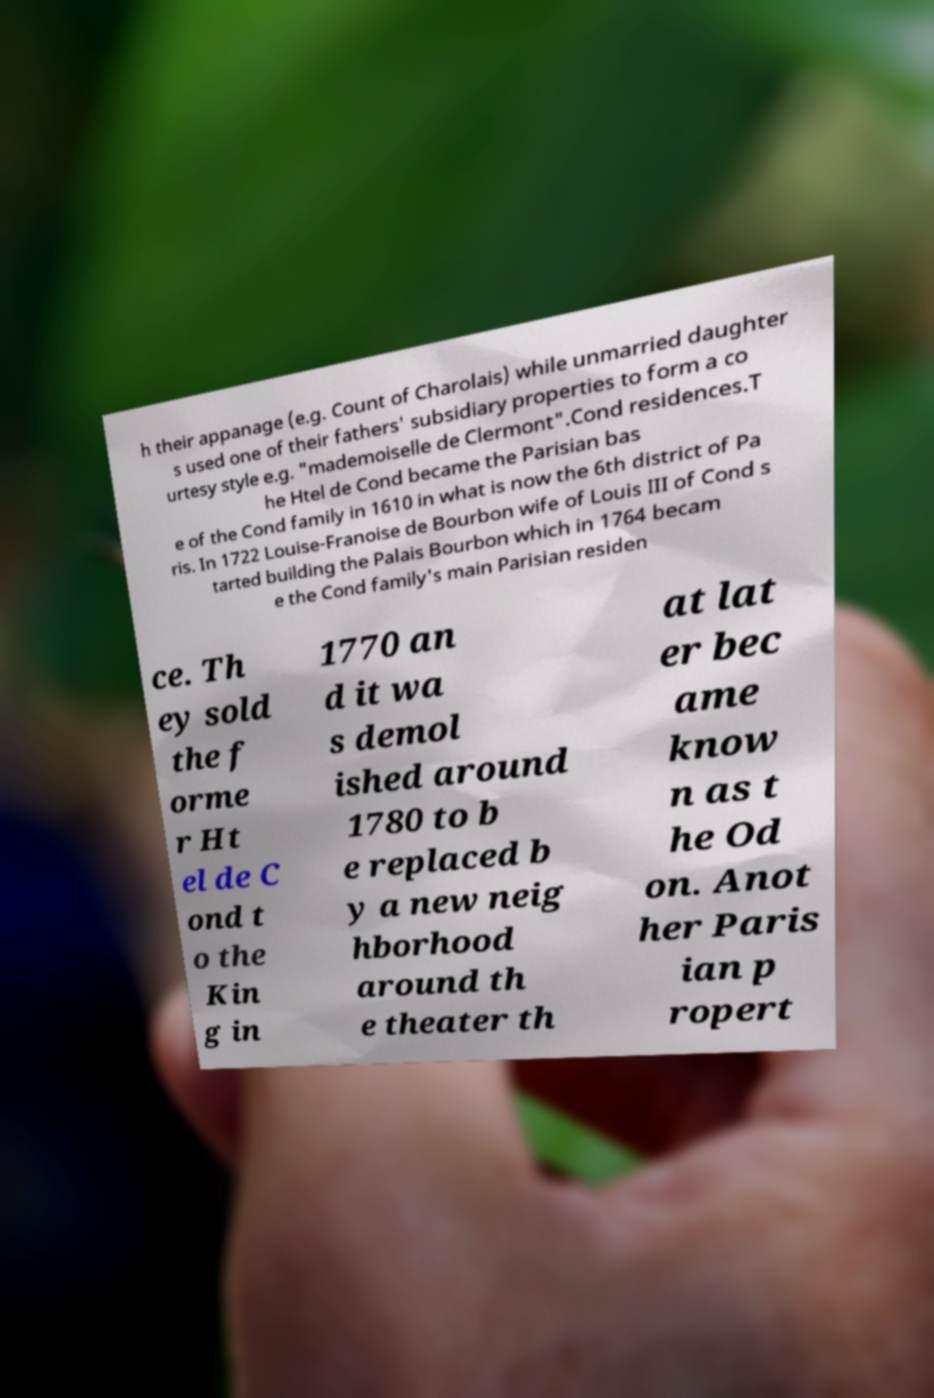For documentation purposes, I need the text within this image transcribed. Could you provide that? h their appanage (e.g. Count of Charolais) while unmarried daughter s used one of their fathers' subsidiary properties to form a co urtesy style e.g. "mademoiselle de Clermont".Cond residences.T he Htel de Cond became the Parisian bas e of the Cond family in 1610 in what is now the 6th district of Pa ris. In 1722 Louise-Franoise de Bourbon wife of Louis III of Cond s tarted building the Palais Bourbon which in 1764 becam e the Cond family's main Parisian residen ce. Th ey sold the f orme r Ht el de C ond t o the Kin g in 1770 an d it wa s demol ished around 1780 to b e replaced b y a new neig hborhood around th e theater th at lat er bec ame know n as t he Od on. Anot her Paris ian p ropert 